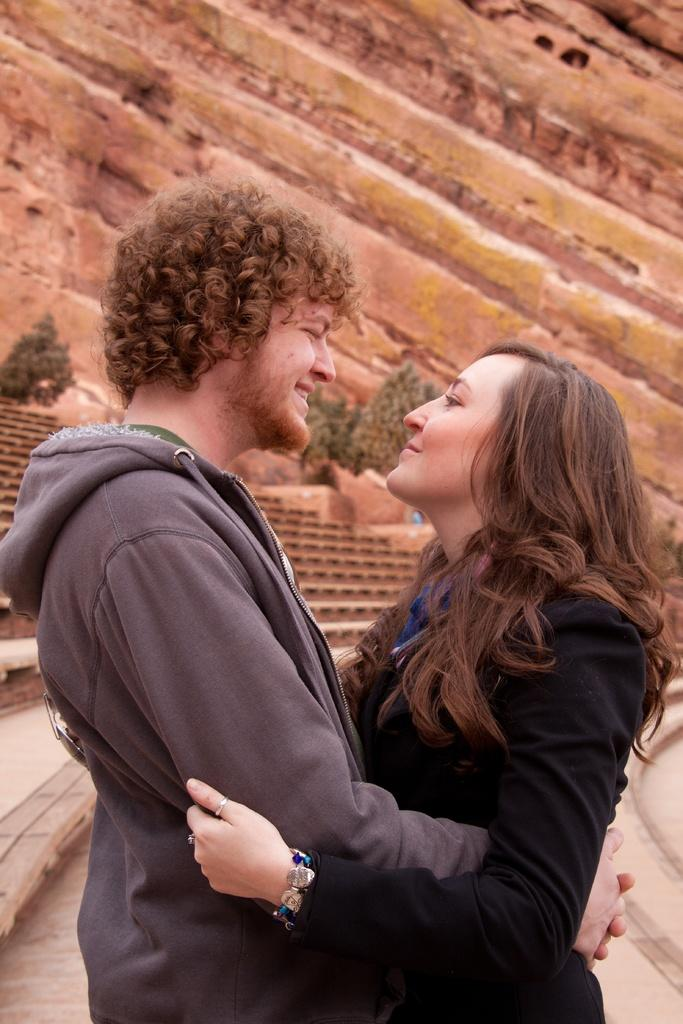How many people are in the image? There are two persons in the image. What are the persons doing in the image? The persons are standing and smiling. What can be seen in the background of the image? There are trees and a staircase in the background of the image. What type of air can be seen flowing through the middle of the image? There is no air visible in the image, and therefore no air flow can be observed. 